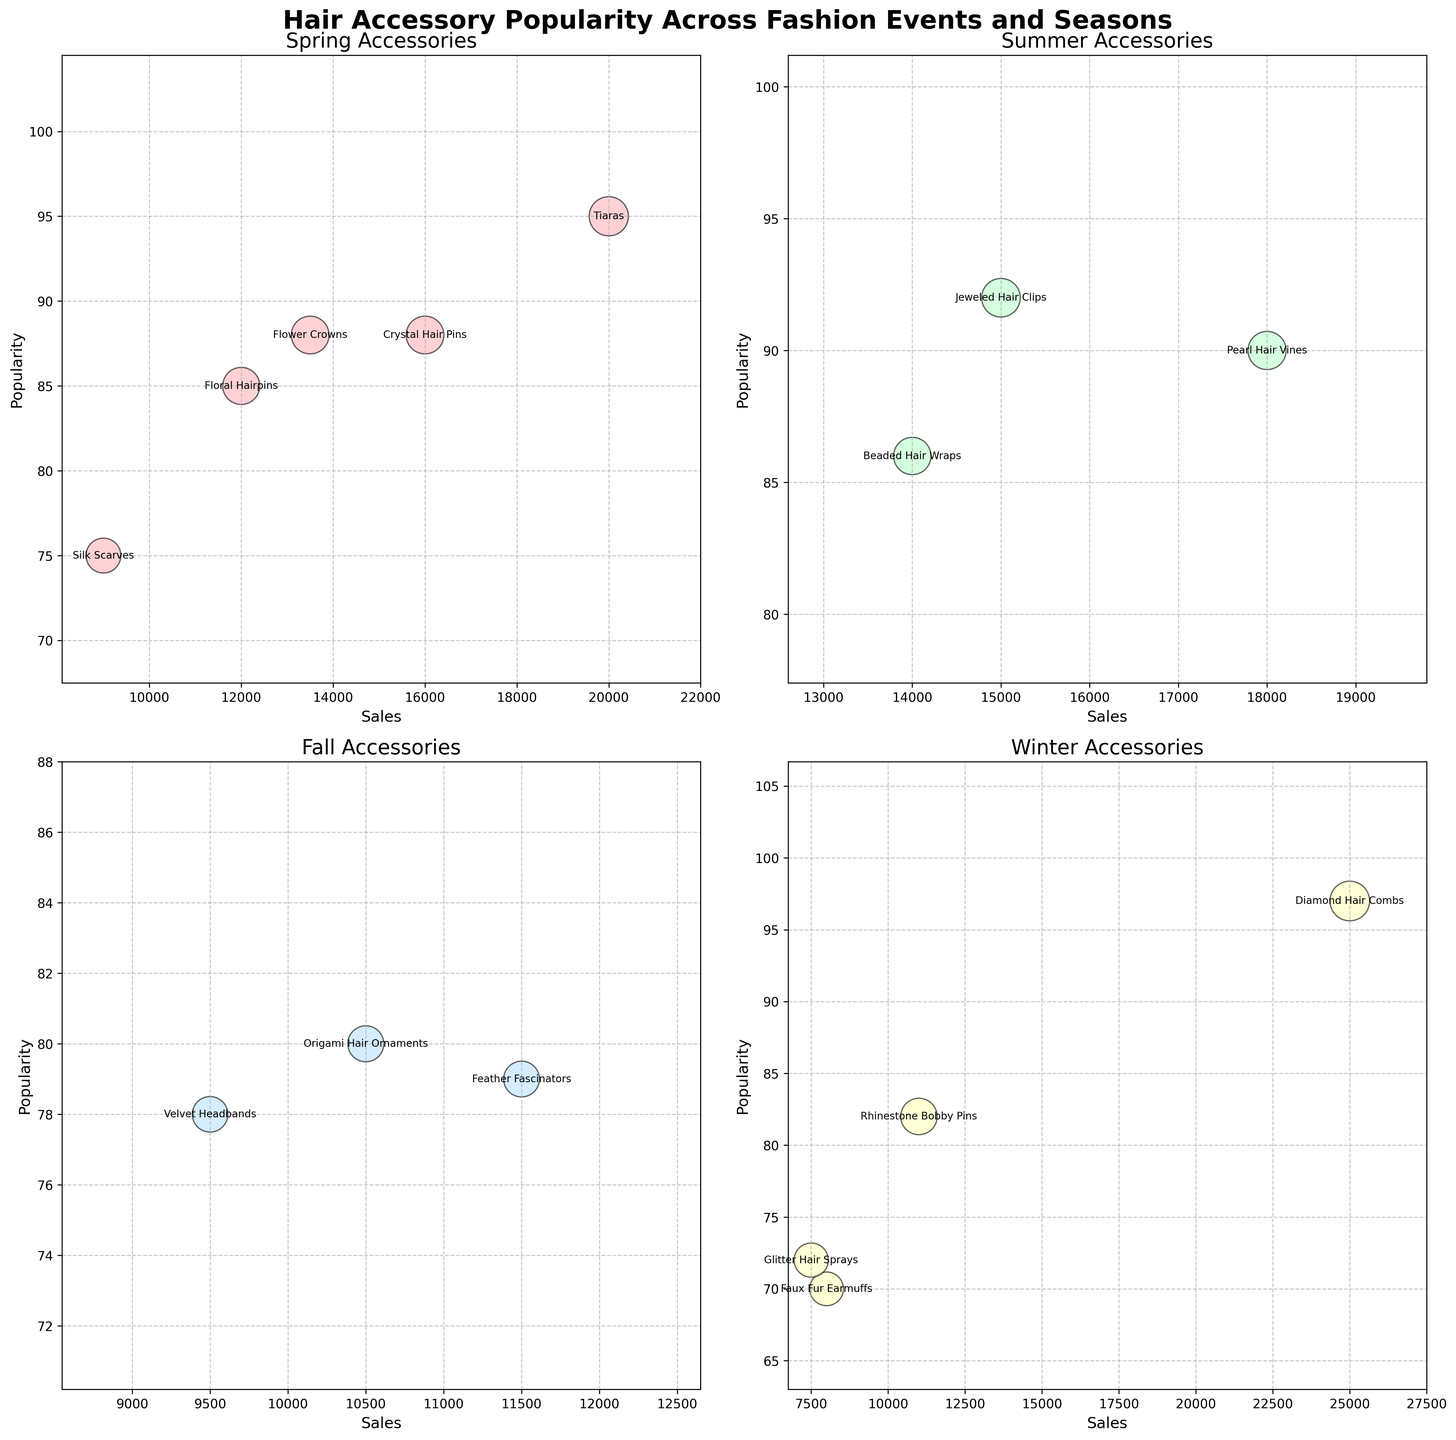what is the overall title of the figure? The overall title of the figure is written at the top and it reads "Hair Accessory Popularity Across Fashion Events and Seasons," which provides a general description of what the plot is about
Answer: Hair Accessory Popularity Across Fashion Events and Seasons In which season does the accessory with the highest sales appear? The scatter plots for each season are examined, and by looking at the x-axis of each subplot, we find the highest sales value in the Winter subplot, corresponding to Diamond Hair Combs with sales of 25000.
Answer: Winter Which accessory has the highest popularity in the Spring season? By looking at the "Spring Accessories" subplot, the accessory with the highest position on the y-axis (Popularity) is Tiaras with a popularity score of 95.
Answer: Tiaras How many accessories have popularity scores higher than 80 in the Summer season? In the "Summer Accessories" subplot, there are three accessories plotted above the y-axis value of 80: Jeweled Hair Clips, Pearl Hair Vines, and Beaded Hair Wraps.
Answer: 3 Which season has the tie for the second highest popularity scores, and what are the accessories? In the "Spring Accessories" subplot, Tiaras have the highest popularity (95), and both Crystal Hair Pins and Flower Crowns are tied for second with a popularity score of 88.
Answer: Spring, Crystal Hair Pins and Flower Crowns What is the total sales value for the accessories displayed in the Fall season? By summing the sales values from the Fall subplot: Velvet Headbands (9500), Origami Hair Ornaments (10500), and Feather Fascinators (11500), we calculate 9500 + 10500 + 11500 = 31500.
Answer: 31500 Among the Winter accessories, which one has the lowest popularity value, and what is it? The "Winter Accessories" subplot shows multiple data points, with the lowest y-axis value corresponding to Glitter Hair Sprays with a popularity score of 72.
Answer: Glitter Hair Sprays How does the sales value of Flower Crowns in the Spring compare to that of Beaded Hair Wraps in the Summer? By comparing the x-axis values in the Spring and Summer subplots, we see that Flower Crowns have sales of 13500, while Beaded Hair Wraps have sales of 14000. Therefore, Flower Crowns' sales are slightly lower.
Answer: Slightly lower What is the average popularity of the accessories in the Winter season? By summing the popularity values for Winter accessories: Rhinestone Bobby Pins (82), Diamond Hair Combs (97), Faux Fur Earmuffs (70), and Glitter Hair Sprays (72), and dividing by the number of accessories, (82 + 97 + 70 + 72) / 4 = 80.25.
Answer: 80.25 Which accessory has both high popularity and high sales in the Spring season? In the Spring subplot, Tiaras are located at the upper-right area, which corresponds to both high popularity (95) and high sales (20000).
Answer: Tiaras 